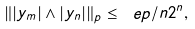Convert formula to latex. <formula><loc_0><loc_0><loc_500><loc_500>\| | y _ { m } | \wedge | y _ { n } | \| _ { p } \leq \ e p / n 2 ^ { n } ,</formula> 